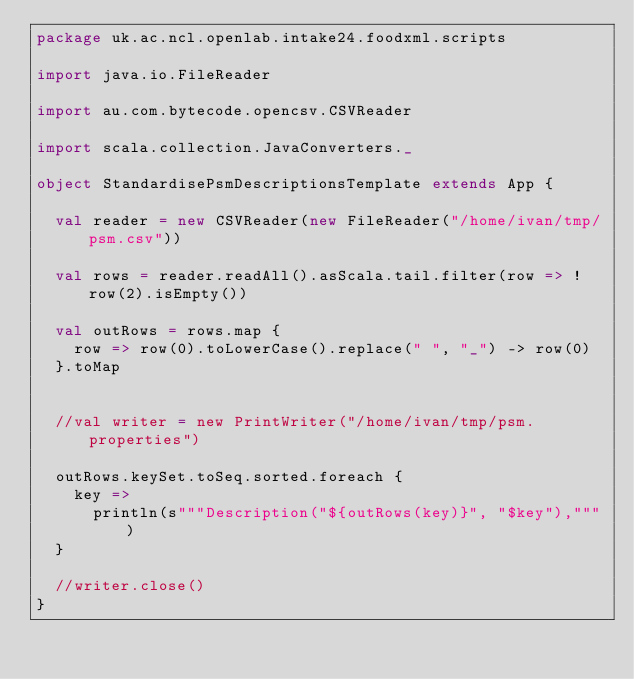<code> <loc_0><loc_0><loc_500><loc_500><_Scala_>package uk.ac.ncl.openlab.intake24.foodxml.scripts

import java.io.FileReader

import au.com.bytecode.opencsv.CSVReader

import scala.collection.JavaConverters._

object StandardisePsmDescriptionsTemplate extends App {

  val reader = new CSVReader(new FileReader("/home/ivan/tmp/psm.csv"))

  val rows = reader.readAll().asScala.tail.filter(row => !row(2).isEmpty())

  val outRows = rows.map {
    row => row(0).toLowerCase().replace(" ", "_") -> row(0)
  }.toMap


  //val writer = new PrintWriter("/home/ivan/tmp/psm.properties")

  outRows.keySet.toSeq.sorted.foreach {
    key =>
      println(s"""Description("${outRows(key)}", "$key"),""")
  }

  //writer.close()
}</code> 